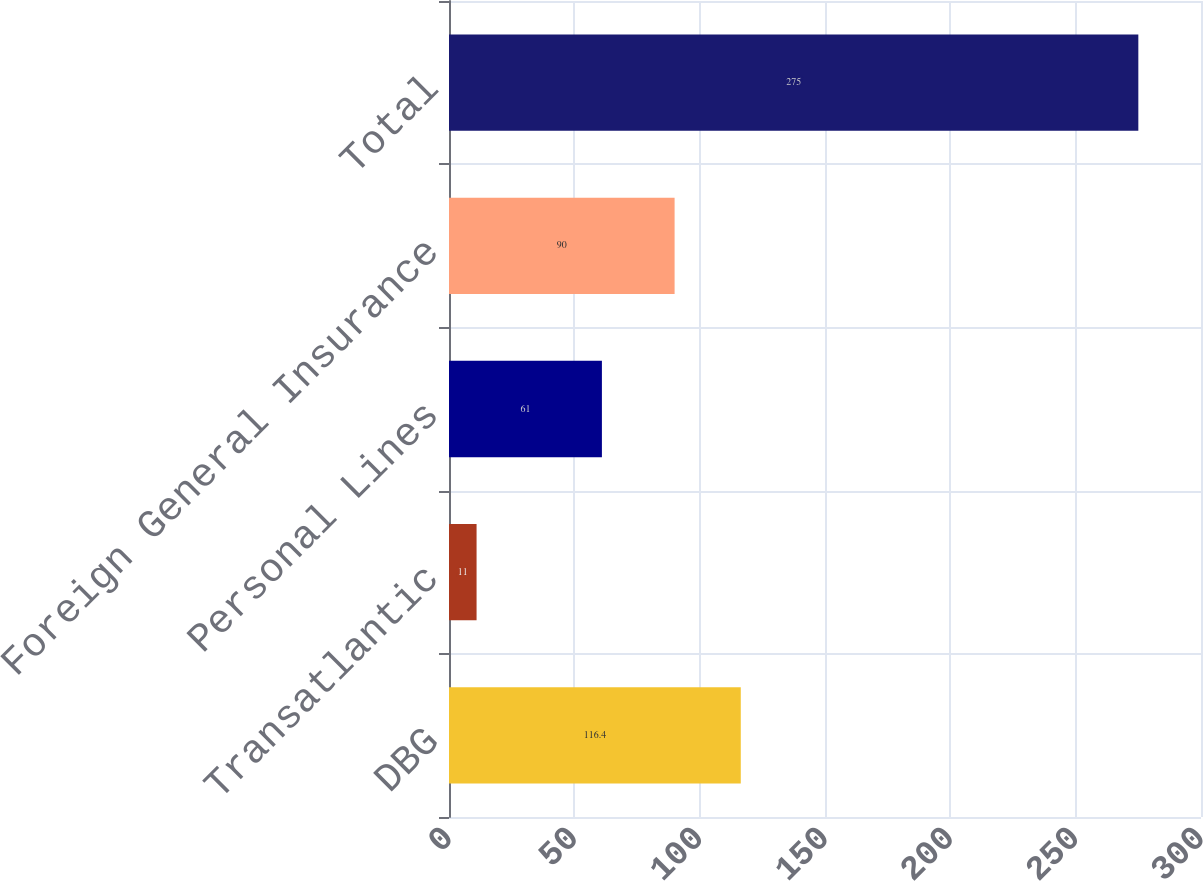Convert chart. <chart><loc_0><loc_0><loc_500><loc_500><bar_chart><fcel>DBG<fcel>Transatlantic<fcel>Personal Lines<fcel>Foreign General Insurance<fcel>Total<nl><fcel>116.4<fcel>11<fcel>61<fcel>90<fcel>275<nl></chart> 